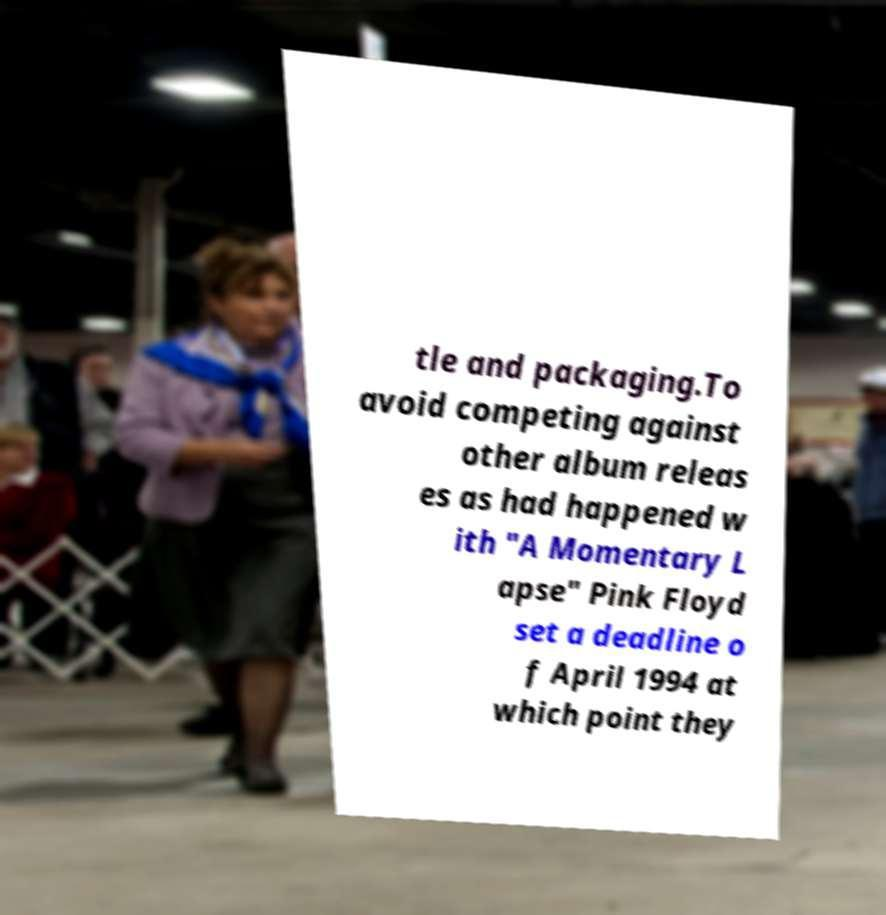There's text embedded in this image that I need extracted. Can you transcribe it verbatim? tle and packaging.To avoid competing against other album releas es as had happened w ith "A Momentary L apse" Pink Floyd set a deadline o f April 1994 at which point they 